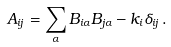<formula> <loc_0><loc_0><loc_500><loc_500>A _ { i j } = \sum _ { \alpha } B _ { i \alpha } B _ { j \alpha } - k _ { i } \delta _ { i j } \, .</formula> 